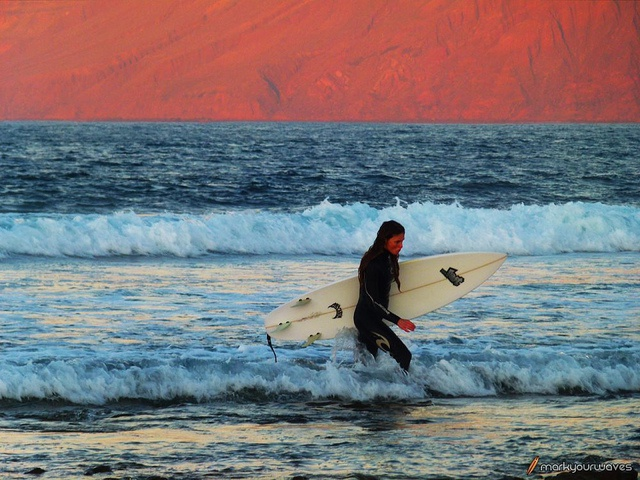Describe the objects in this image and their specific colors. I can see surfboard in brown, tan, and gray tones and people in brown, black, gray, and maroon tones in this image. 